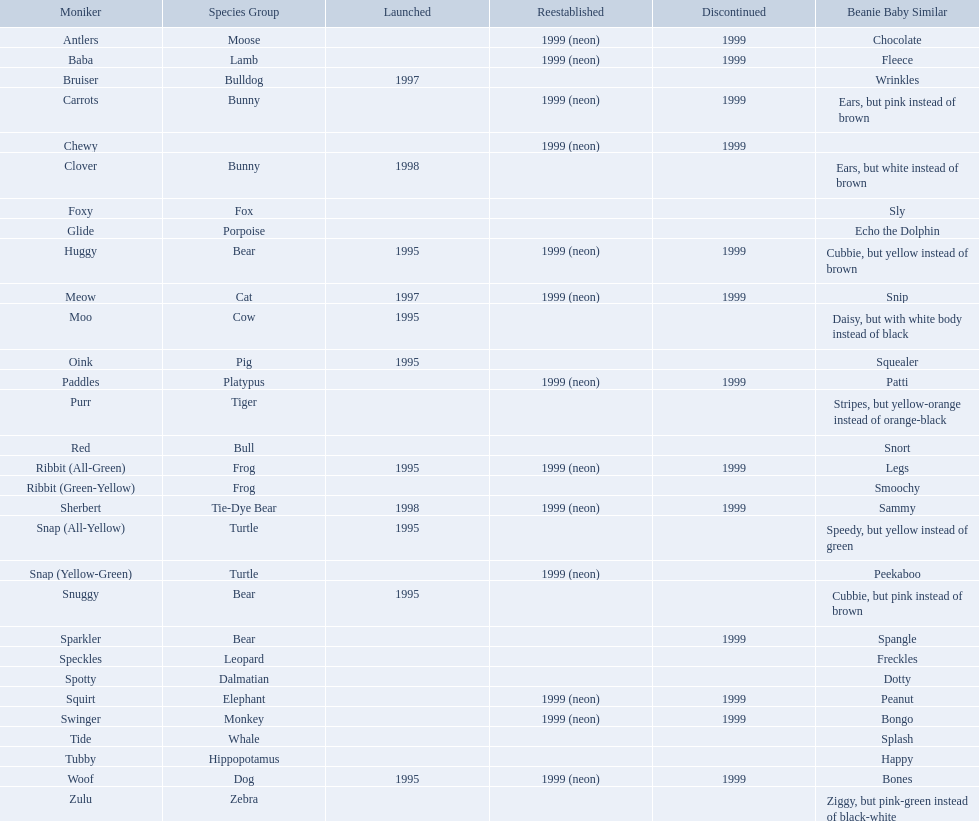What are all the different names of the pillow pals? Antlers, Baba, Bruiser, Carrots, Chewy, Clover, Foxy, Glide, Huggy, Meow, Moo, Oink, Paddles, Purr, Red, Ribbit (All-Green), Ribbit (Green-Yellow), Sherbert, Snap (All-Yellow), Snap (Yellow-Green), Snuggy, Sparkler, Speckles, Spotty, Squirt, Swinger, Tide, Tubby, Woof, Zulu. Which of these are a dalmatian? Spotty. What animals are pillow pals? Moose, Lamb, Bulldog, Bunny, Bunny, Fox, Porpoise, Bear, Cat, Cow, Pig, Platypus, Tiger, Bull, Frog, Frog, Tie-Dye Bear, Turtle, Turtle, Bear, Bear, Leopard, Dalmatian, Elephant, Monkey, Whale, Hippopotamus, Dog, Zebra. What is the name of the dalmatian? Spotty. 